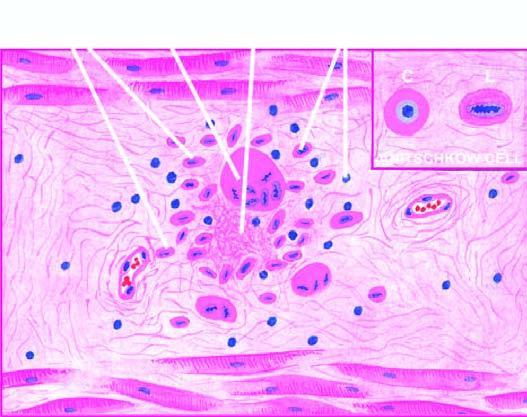does infarcted area show owl-eye appearance of central chromatin mass and perinuclear halo?
Answer the question using a single word or phrase. No 